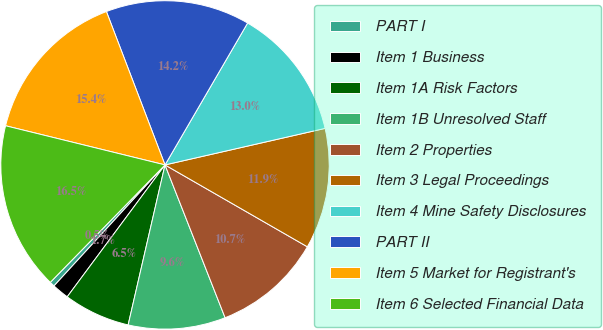Convert chart. <chart><loc_0><loc_0><loc_500><loc_500><pie_chart><fcel>PART I<fcel>Item 1 Business<fcel>Item 1A Risk Factors<fcel>Item 1B Unresolved Staff<fcel>Item 2 Properties<fcel>Item 3 Legal Proceedings<fcel>Item 4 Mine Safety Disclosures<fcel>PART II<fcel>Item 5 Market for Registrant's<fcel>Item 6 Selected Financial Data<nl><fcel>0.5%<fcel>1.66%<fcel>6.55%<fcel>9.57%<fcel>10.73%<fcel>11.88%<fcel>13.04%<fcel>14.2%<fcel>15.36%<fcel>16.52%<nl></chart> 